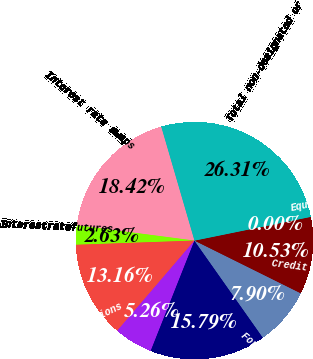<chart> <loc_0><loc_0><loc_500><loc_500><pie_chart><fcel>Interest rate swaps<fcel>Interestratefutures<fcel>Interestrateoptions<fcel>Interest rate forwards<fcel>Foreign currency swaps<fcel>Foreign currency forwards<fcel>Credit default swaps<fcel>Equityfutures<fcel>Total non-designated or<nl><fcel>18.42%<fcel>2.63%<fcel>13.16%<fcel>5.26%<fcel>15.79%<fcel>7.9%<fcel>10.53%<fcel>0.0%<fcel>26.31%<nl></chart> 